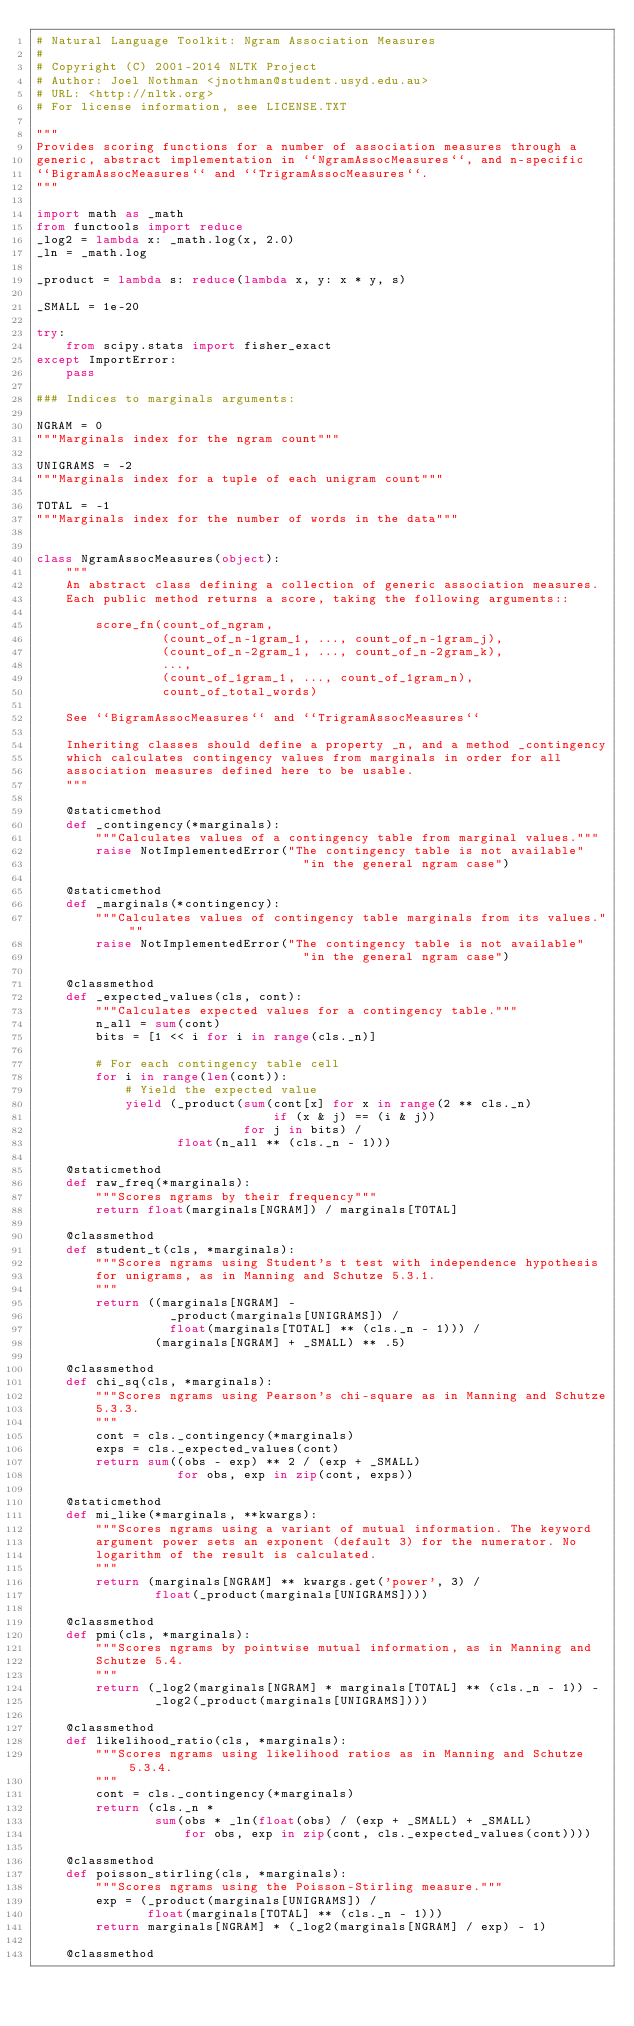<code> <loc_0><loc_0><loc_500><loc_500><_Python_># Natural Language Toolkit: Ngram Association Measures
#
# Copyright (C) 2001-2014 NLTK Project
# Author: Joel Nothman <jnothman@student.usyd.edu.au>
# URL: <http://nltk.org>
# For license information, see LICENSE.TXT

"""
Provides scoring functions for a number of association measures through a
generic, abstract implementation in ``NgramAssocMeasures``, and n-specific
``BigramAssocMeasures`` and ``TrigramAssocMeasures``.
"""

import math as _math
from functools import reduce
_log2 = lambda x: _math.log(x, 2.0)
_ln = _math.log

_product = lambda s: reduce(lambda x, y: x * y, s)

_SMALL = 1e-20

try:
    from scipy.stats import fisher_exact
except ImportError:
    pass

### Indices to marginals arguments:

NGRAM = 0
"""Marginals index for the ngram count"""

UNIGRAMS = -2
"""Marginals index for a tuple of each unigram count"""

TOTAL = -1
"""Marginals index for the number of words in the data"""


class NgramAssocMeasures(object):
    """
    An abstract class defining a collection of generic association measures.
    Each public method returns a score, taking the following arguments::

        score_fn(count_of_ngram,
                 (count_of_n-1gram_1, ..., count_of_n-1gram_j),
                 (count_of_n-2gram_1, ..., count_of_n-2gram_k),
                 ...,
                 (count_of_1gram_1, ..., count_of_1gram_n),
                 count_of_total_words)

    See ``BigramAssocMeasures`` and ``TrigramAssocMeasures``

    Inheriting classes should define a property _n, and a method _contingency
    which calculates contingency values from marginals in order for all
    association measures defined here to be usable.
    """

    @staticmethod
    def _contingency(*marginals):
        """Calculates values of a contingency table from marginal values."""
        raise NotImplementedError("The contingency table is not available"
                                    "in the general ngram case")

    @staticmethod
    def _marginals(*contingency):
        """Calculates values of contingency table marginals from its values."""
        raise NotImplementedError("The contingency table is not available"
                                    "in the general ngram case")

    @classmethod
    def _expected_values(cls, cont):
        """Calculates expected values for a contingency table."""
        n_all = sum(cont)
        bits = [1 << i for i in range(cls._n)]

        # For each contingency table cell
        for i in range(len(cont)):
            # Yield the expected value
            yield (_product(sum(cont[x] for x in range(2 ** cls._n)
                                if (x & j) == (i & j))
                            for j in bits) /
                   float(n_all ** (cls._n - 1)))

    @staticmethod
    def raw_freq(*marginals):
        """Scores ngrams by their frequency"""
        return float(marginals[NGRAM]) / marginals[TOTAL]

    @classmethod
    def student_t(cls, *marginals):
        """Scores ngrams using Student's t test with independence hypothesis
        for unigrams, as in Manning and Schutze 5.3.1.
        """
        return ((marginals[NGRAM] -
                  _product(marginals[UNIGRAMS]) /
                  float(marginals[TOTAL] ** (cls._n - 1))) /
                (marginals[NGRAM] + _SMALL) ** .5)

    @classmethod
    def chi_sq(cls, *marginals):
        """Scores ngrams using Pearson's chi-square as in Manning and Schutze
        5.3.3.
        """
        cont = cls._contingency(*marginals)
        exps = cls._expected_values(cont)
        return sum((obs - exp) ** 2 / (exp + _SMALL)
                   for obs, exp in zip(cont, exps))

    @staticmethod
    def mi_like(*marginals, **kwargs):
        """Scores ngrams using a variant of mutual information. The keyword
        argument power sets an exponent (default 3) for the numerator. No
        logarithm of the result is calculated.
        """
        return (marginals[NGRAM] ** kwargs.get('power', 3) /
                float(_product(marginals[UNIGRAMS])))

    @classmethod
    def pmi(cls, *marginals):
        """Scores ngrams by pointwise mutual information, as in Manning and
        Schutze 5.4.
        """
        return (_log2(marginals[NGRAM] * marginals[TOTAL] ** (cls._n - 1)) -
                _log2(_product(marginals[UNIGRAMS])))

    @classmethod
    def likelihood_ratio(cls, *marginals):
        """Scores ngrams using likelihood ratios as in Manning and Schutze 5.3.4.
        """
        cont = cls._contingency(*marginals)
        return (cls._n *
                sum(obs * _ln(float(obs) / (exp + _SMALL) + _SMALL)
                    for obs, exp in zip(cont, cls._expected_values(cont))))

    @classmethod
    def poisson_stirling(cls, *marginals):
        """Scores ngrams using the Poisson-Stirling measure."""
        exp = (_product(marginals[UNIGRAMS]) /
               float(marginals[TOTAL] ** (cls._n - 1)))
        return marginals[NGRAM] * (_log2(marginals[NGRAM] / exp) - 1)

    @classmethod</code> 